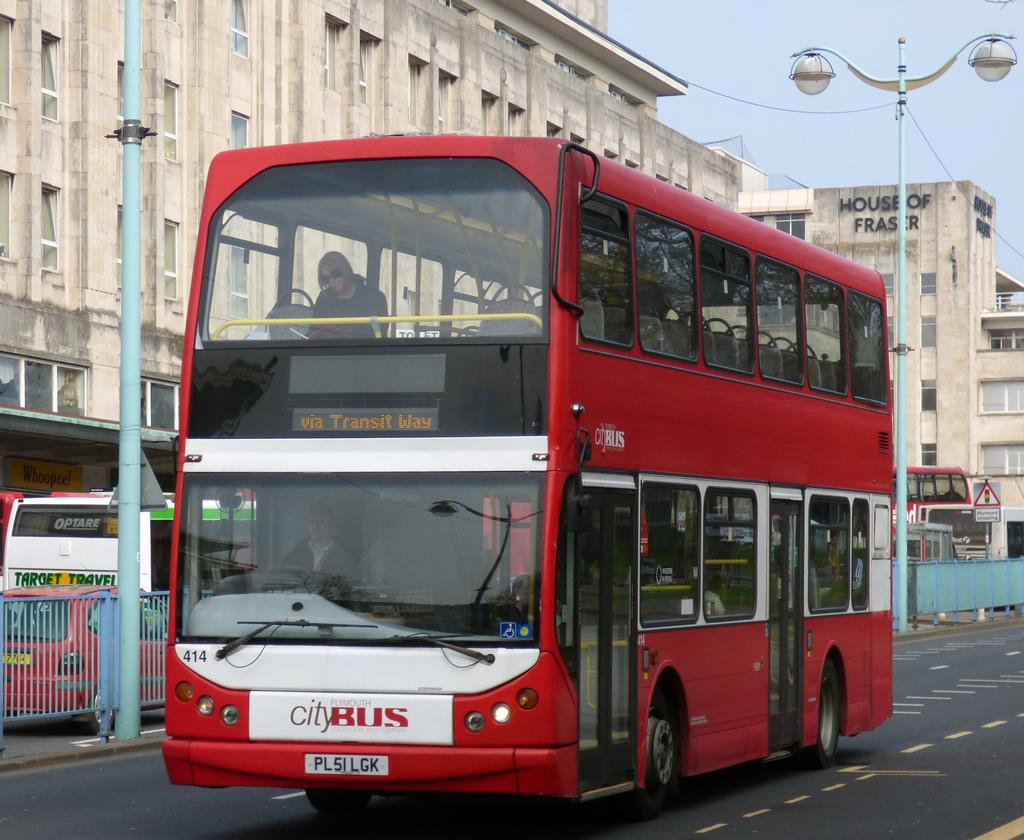<image>
Render a clear and concise summary of the photo. Red double-decker City Bus with an electronic sign that says via Transit Way 